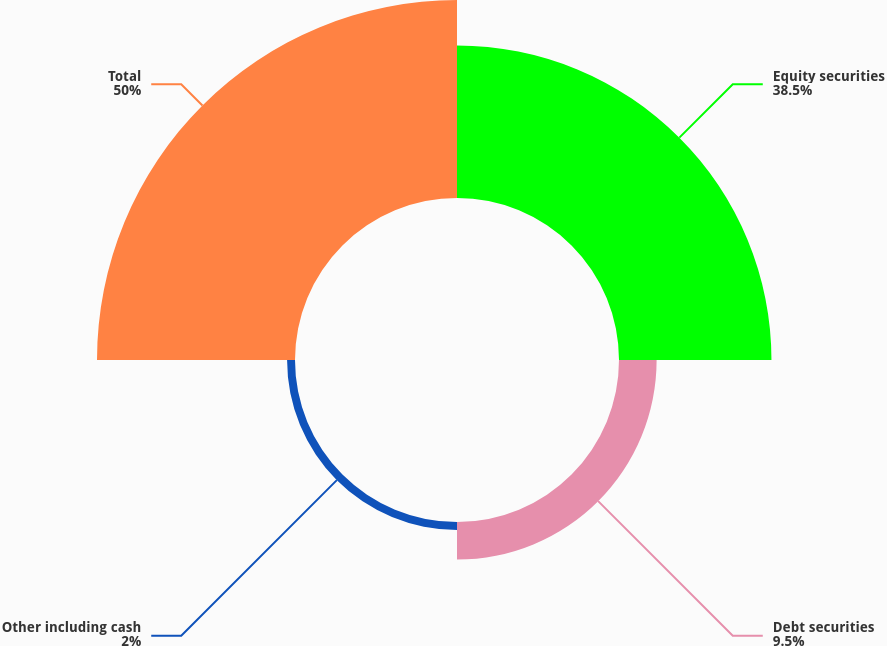Convert chart to OTSL. <chart><loc_0><loc_0><loc_500><loc_500><pie_chart><fcel>Equity securities<fcel>Debt securities<fcel>Other including cash<fcel>Total<nl><fcel>38.5%<fcel>9.5%<fcel>2.0%<fcel>50.0%<nl></chart> 